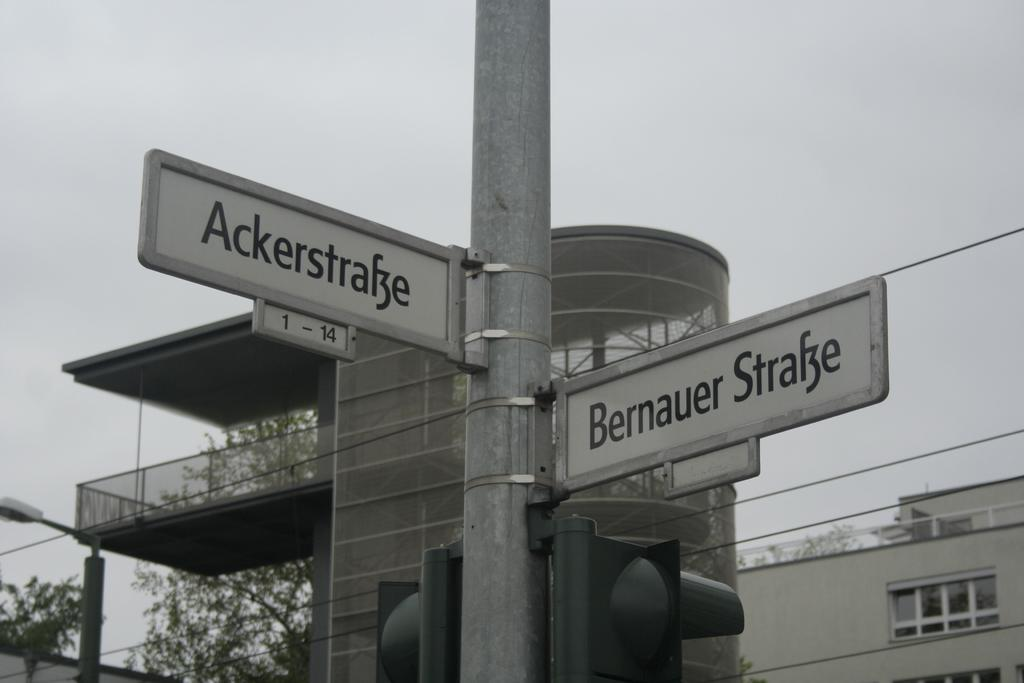<image>
Provide a brief description of the given image. Stoplights at the intersection of AckerstraBe and Bernauer StraBe 